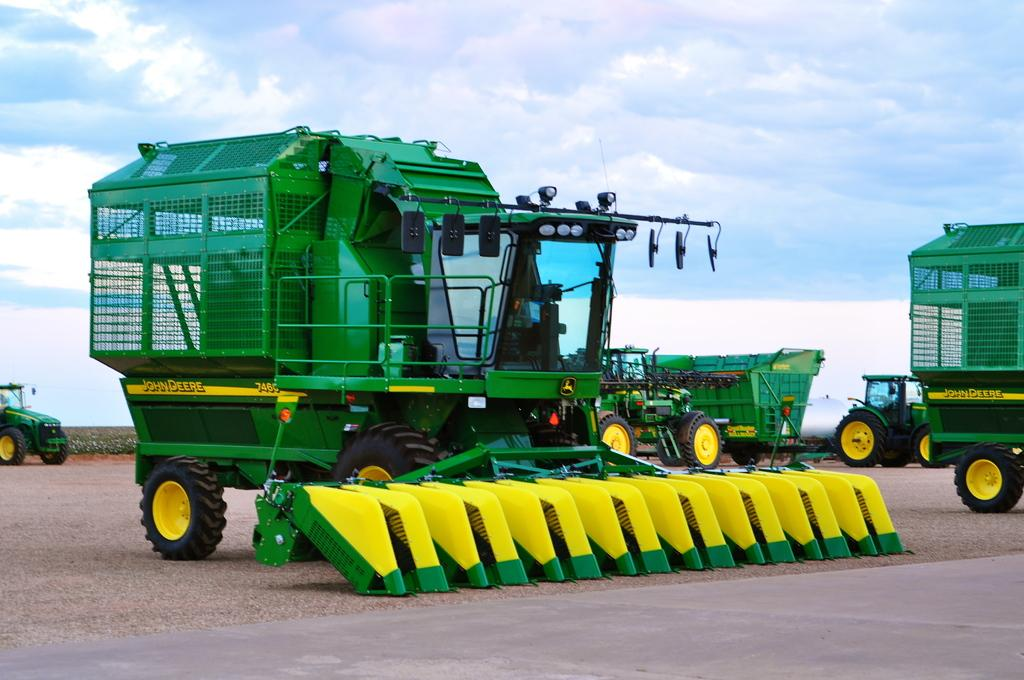What is the main subject of the image? The main subject of the image is many vehicles. What is the condition of the sky in the image? The sky is cloudy in the image. What can be seen in the background of the image? There are many flags in the background of the image. What scientific discovery can be seen being made in the image? There is no scientific discovery present in the image. What type of bridge can be seen in the image? There is no bridge present in the image. What journey are the vehicles taking in the image? The image does not provide information about the vehicles' journey. 